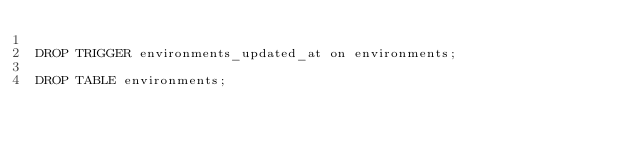Convert code to text. <code><loc_0><loc_0><loc_500><loc_500><_SQL_>
DROP TRIGGER environments_updated_at on environments;

DROP TABLE environments;
</code> 